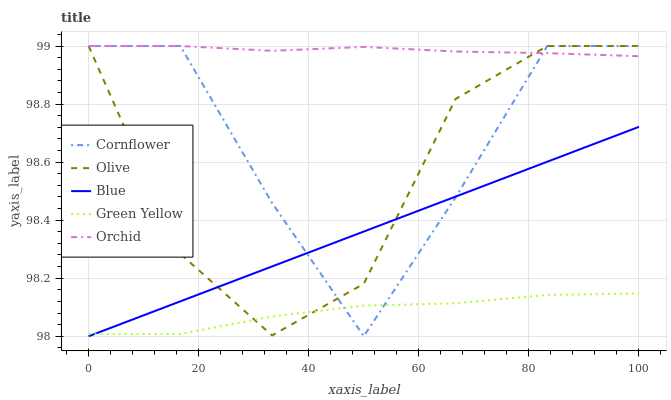Does Green Yellow have the minimum area under the curve?
Answer yes or no. Yes. Does Orchid have the maximum area under the curve?
Answer yes or no. Yes. Does Cornflower have the minimum area under the curve?
Answer yes or no. No. Does Cornflower have the maximum area under the curve?
Answer yes or no. No. Is Blue the smoothest?
Answer yes or no. Yes. Is Cornflower the roughest?
Answer yes or no. Yes. Is Green Yellow the smoothest?
Answer yes or no. No. Is Green Yellow the roughest?
Answer yes or no. No. Does Blue have the lowest value?
Answer yes or no. Yes. Does Cornflower have the lowest value?
Answer yes or no. No. Does Orchid have the highest value?
Answer yes or no. Yes. Does Green Yellow have the highest value?
Answer yes or no. No. Is Blue less than Orchid?
Answer yes or no. Yes. Is Orchid greater than Green Yellow?
Answer yes or no. Yes. Does Green Yellow intersect Cornflower?
Answer yes or no. Yes. Is Green Yellow less than Cornflower?
Answer yes or no. No. Is Green Yellow greater than Cornflower?
Answer yes or no. No. Does Blue intersect Orchid?
Answer yes or no. No. 